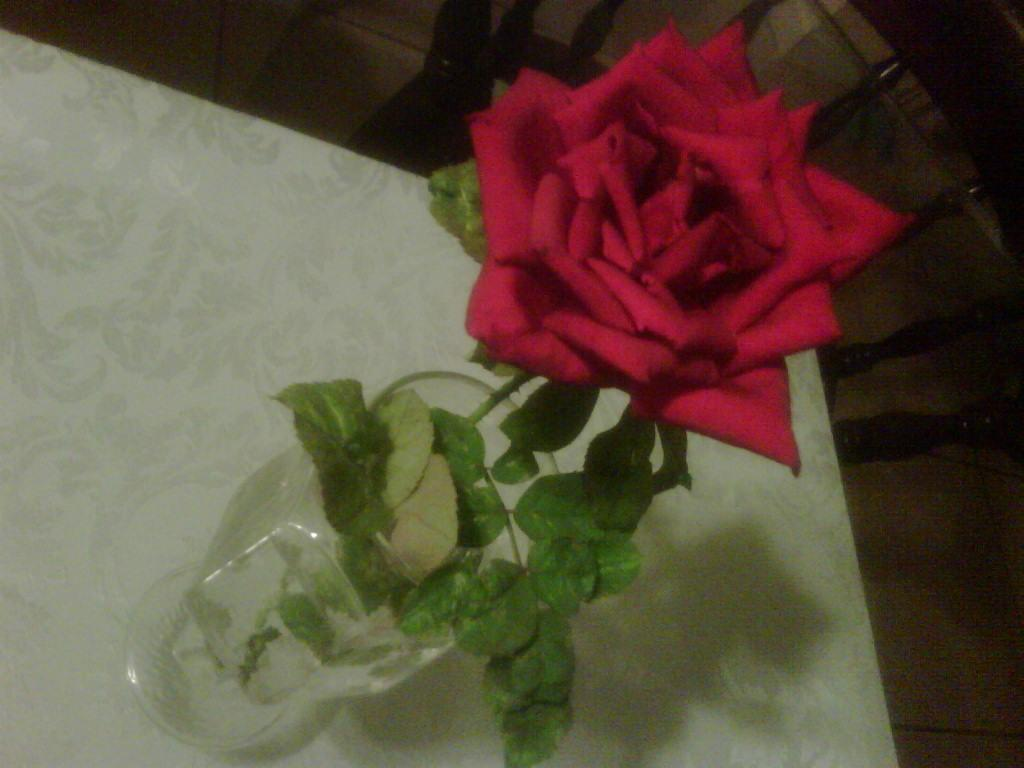What is inside the glass that is visible in the image? There is a glass filled with water in the image, and a rose flower is kept in the water. Where is the glass placed in the image? The glass is placed on a table in the image. What is located beside the table in the image? There is a chair beside the table in the image. What type of celery is being attacked by the current in the image? There is no celery or current present in the image. 